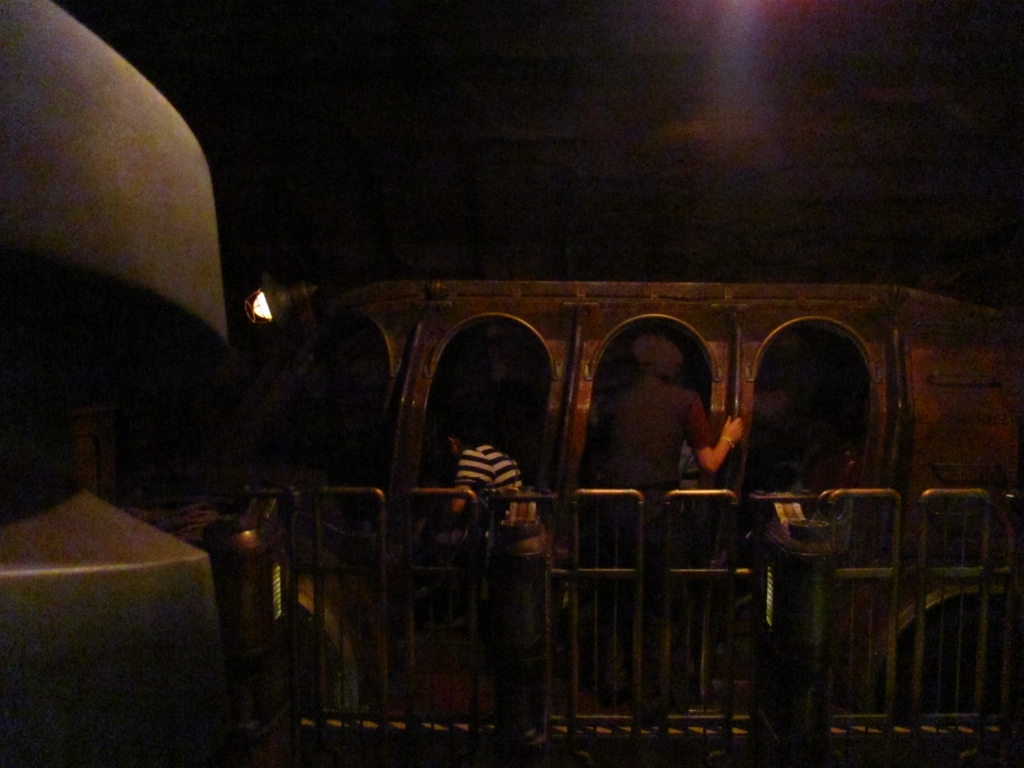What might this place be used for? Given the appearance of the compartments and the dim, atmospheric lighting, this place could be a themed ride that simulates a journey in a classic or fantasy-styled train. It's likely that passengers would be seated in these carriages and taken on an immersive experience, perhaps through different scenes or settings as a form of entertainment. 